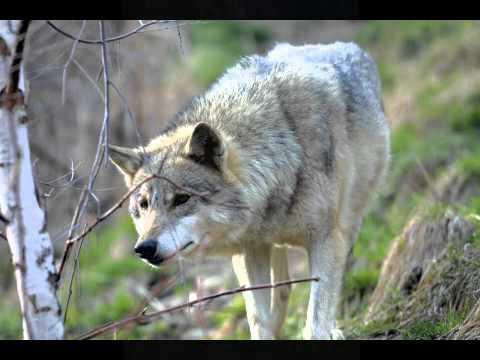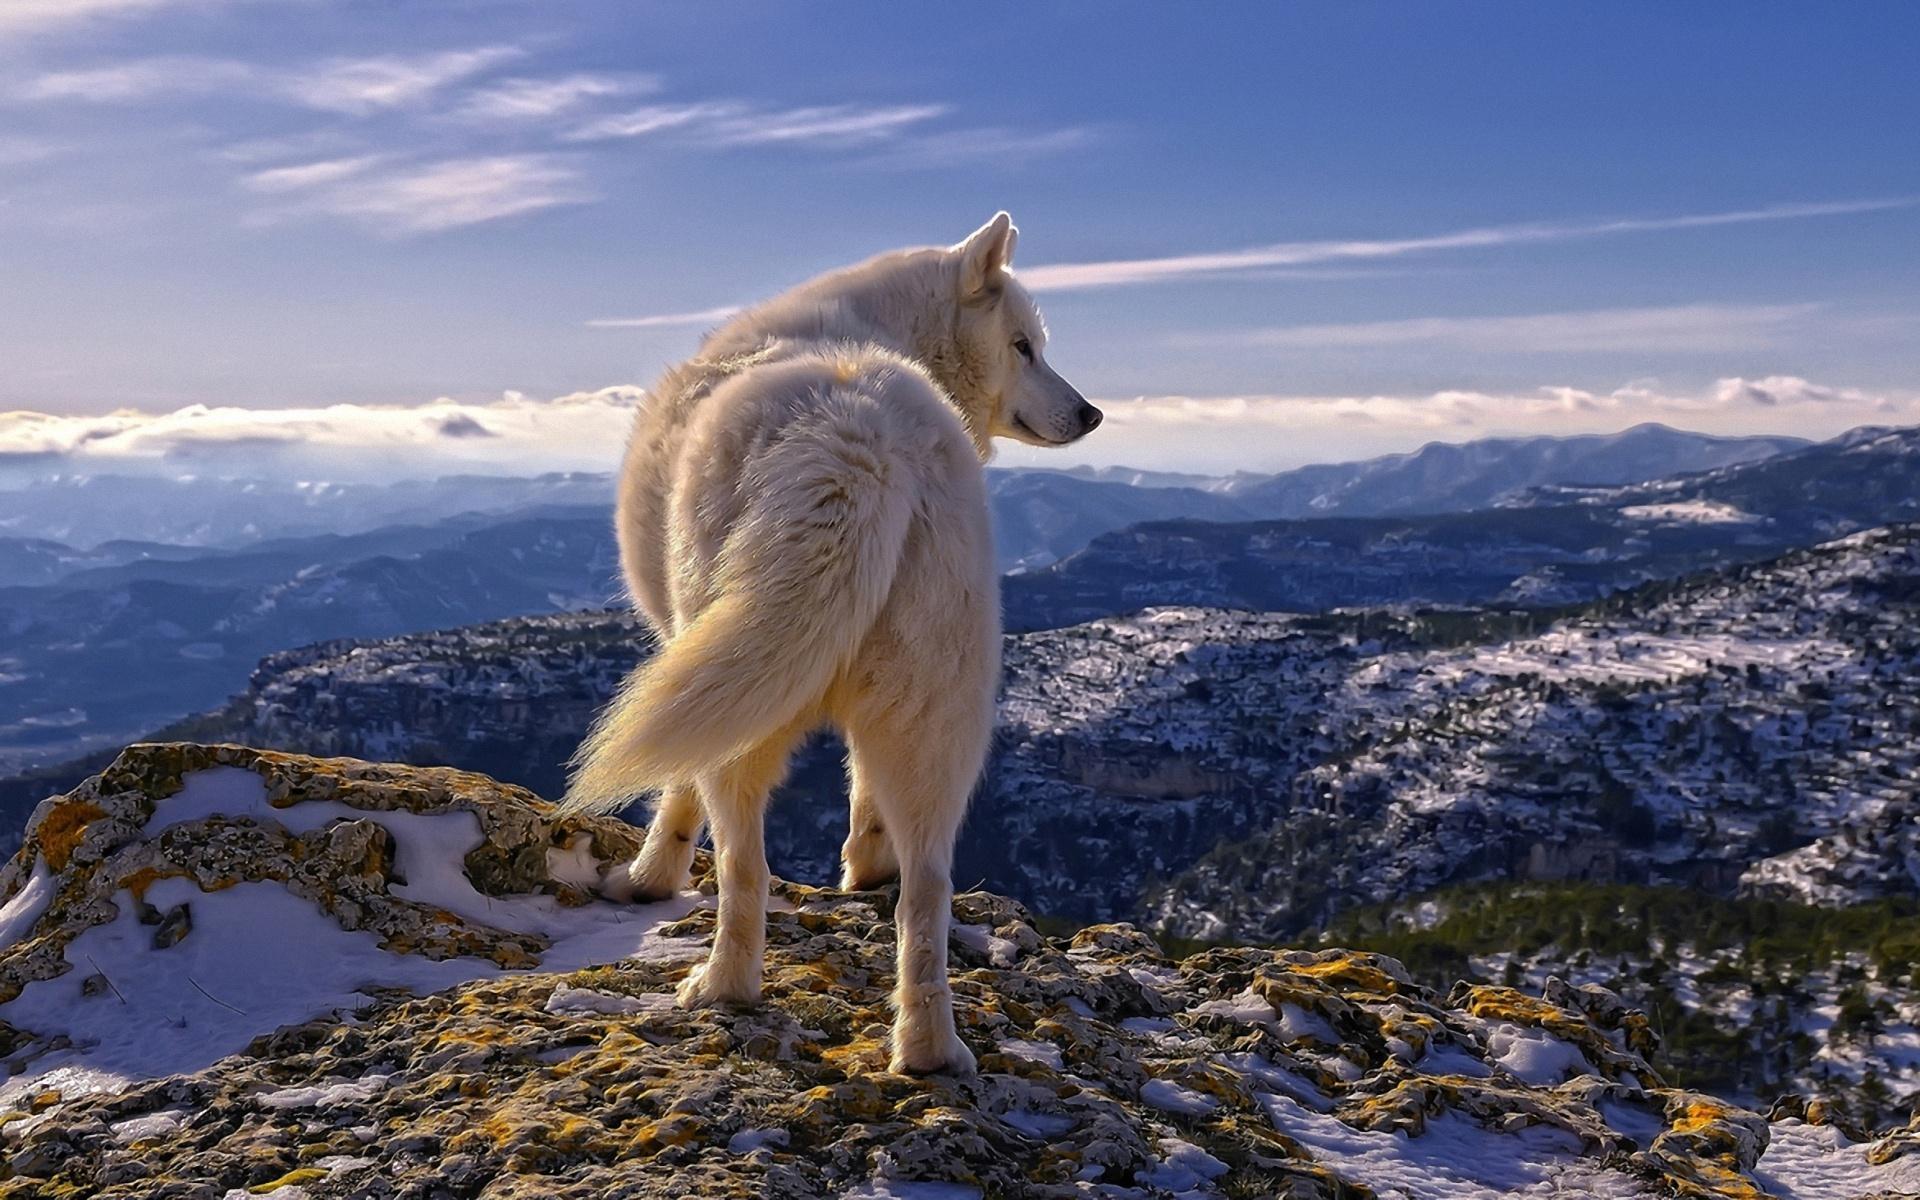The first image is the image on the left, the second image is the image on the right. Analyze the images presented: Is the assertion "A herd of buffalo are behind multiple wolves on snow-covered ground in the right image." valid? Answer yes or no. No. The first image is the image on the left, the second image is the image on the right. Considering the images on both sides, is "The right image contains exactly one wolf." valid? Answer yes or no. Yes. 